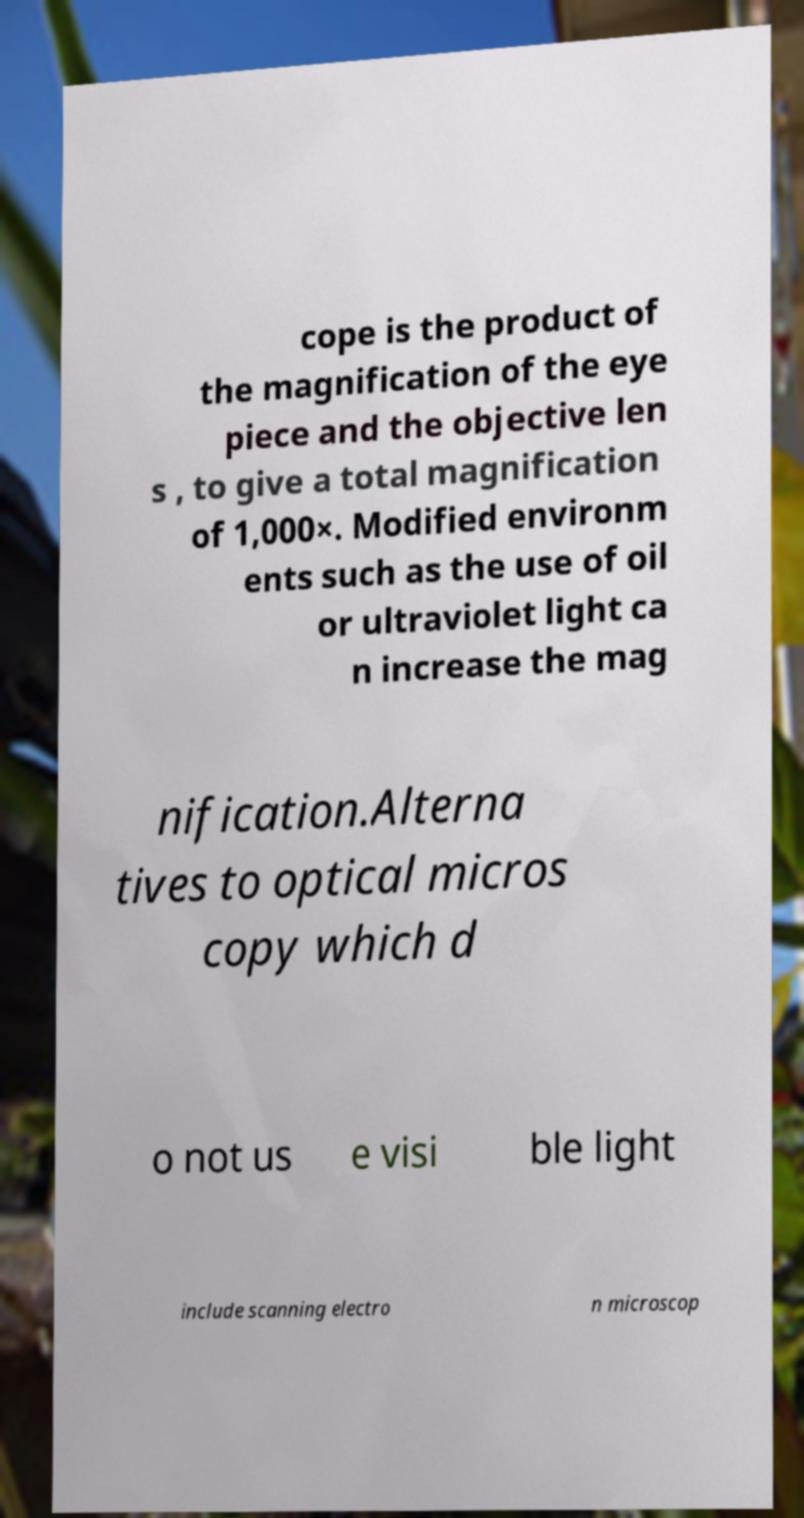Can you accurately transcribe the text from the provided image for me? cope is the product of the magnification of the eye piece and the objective len s , to give a total magnification of 1,000×. Modified environm ents such as the use of oil or ultraviolet light ca n increase the mag nification.Alterna tives to optical micros copy which d o not us e visi ble light include scanning electro n microscop 